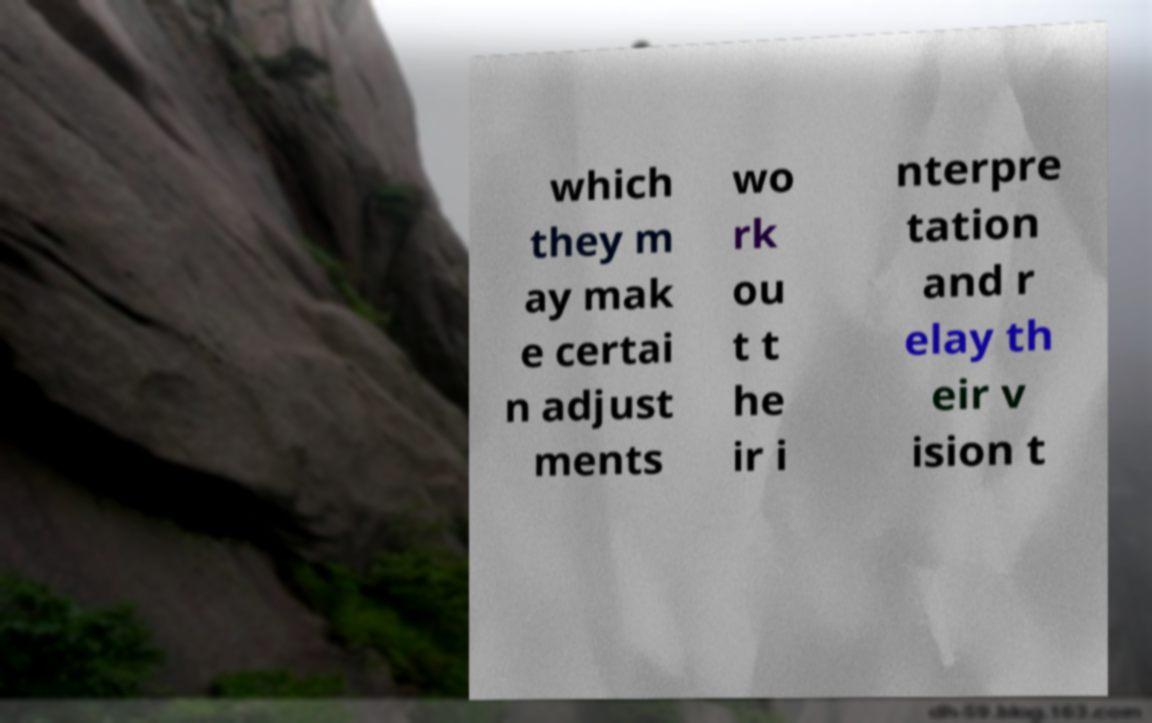Can you accurately transcribe the text from the provided image for me? which they m ay mak e certai n adjust ments wo rk ou t t he ir i nterpre tation and r elay th eir v ision t 